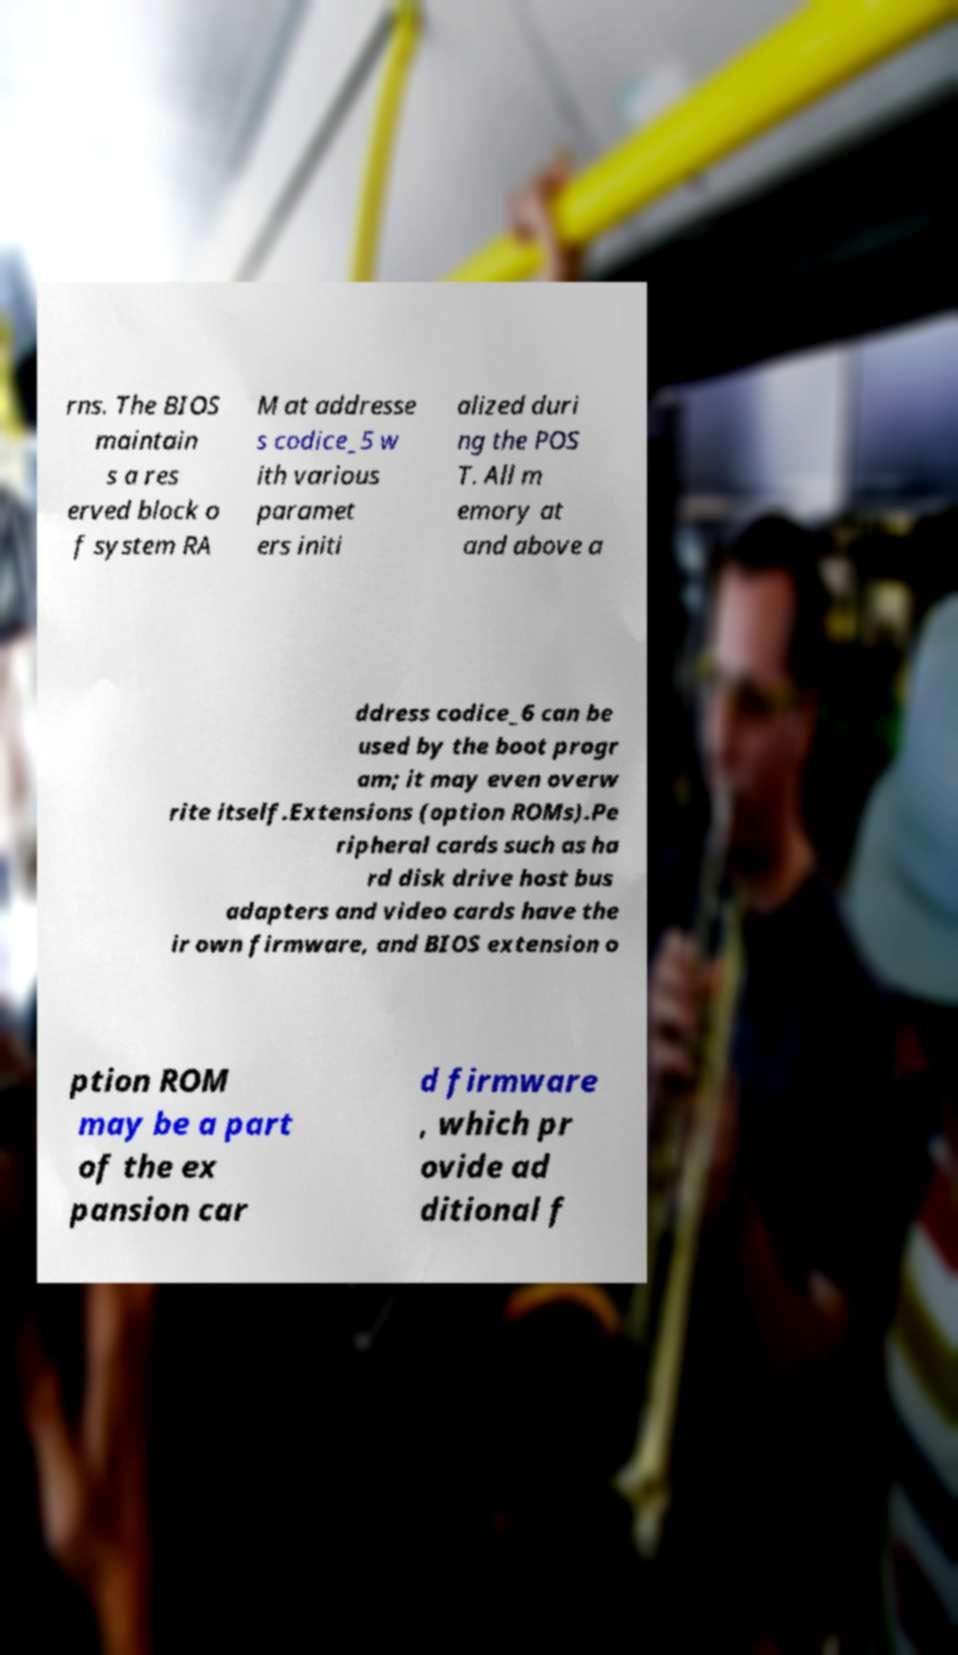Please identify and transcribe the text found in this image. rns. The BIOS maintain s a res erved block o f system RA M at addresse s codice_5 w ith various paramet ers initi alized duri ng the POS T. All m emory at and above a ddress codice_6 can be used by the boot progr am; it may even overw rite itself.Extensions (option ROMs).Pe ripheral cards such as ha rd disk drive host bus adapters and video cards have the ir own firmware, and BIOS extension o ption ROM may be a part of the ex pansion car d firmware , which pr ovide ad ditional f 